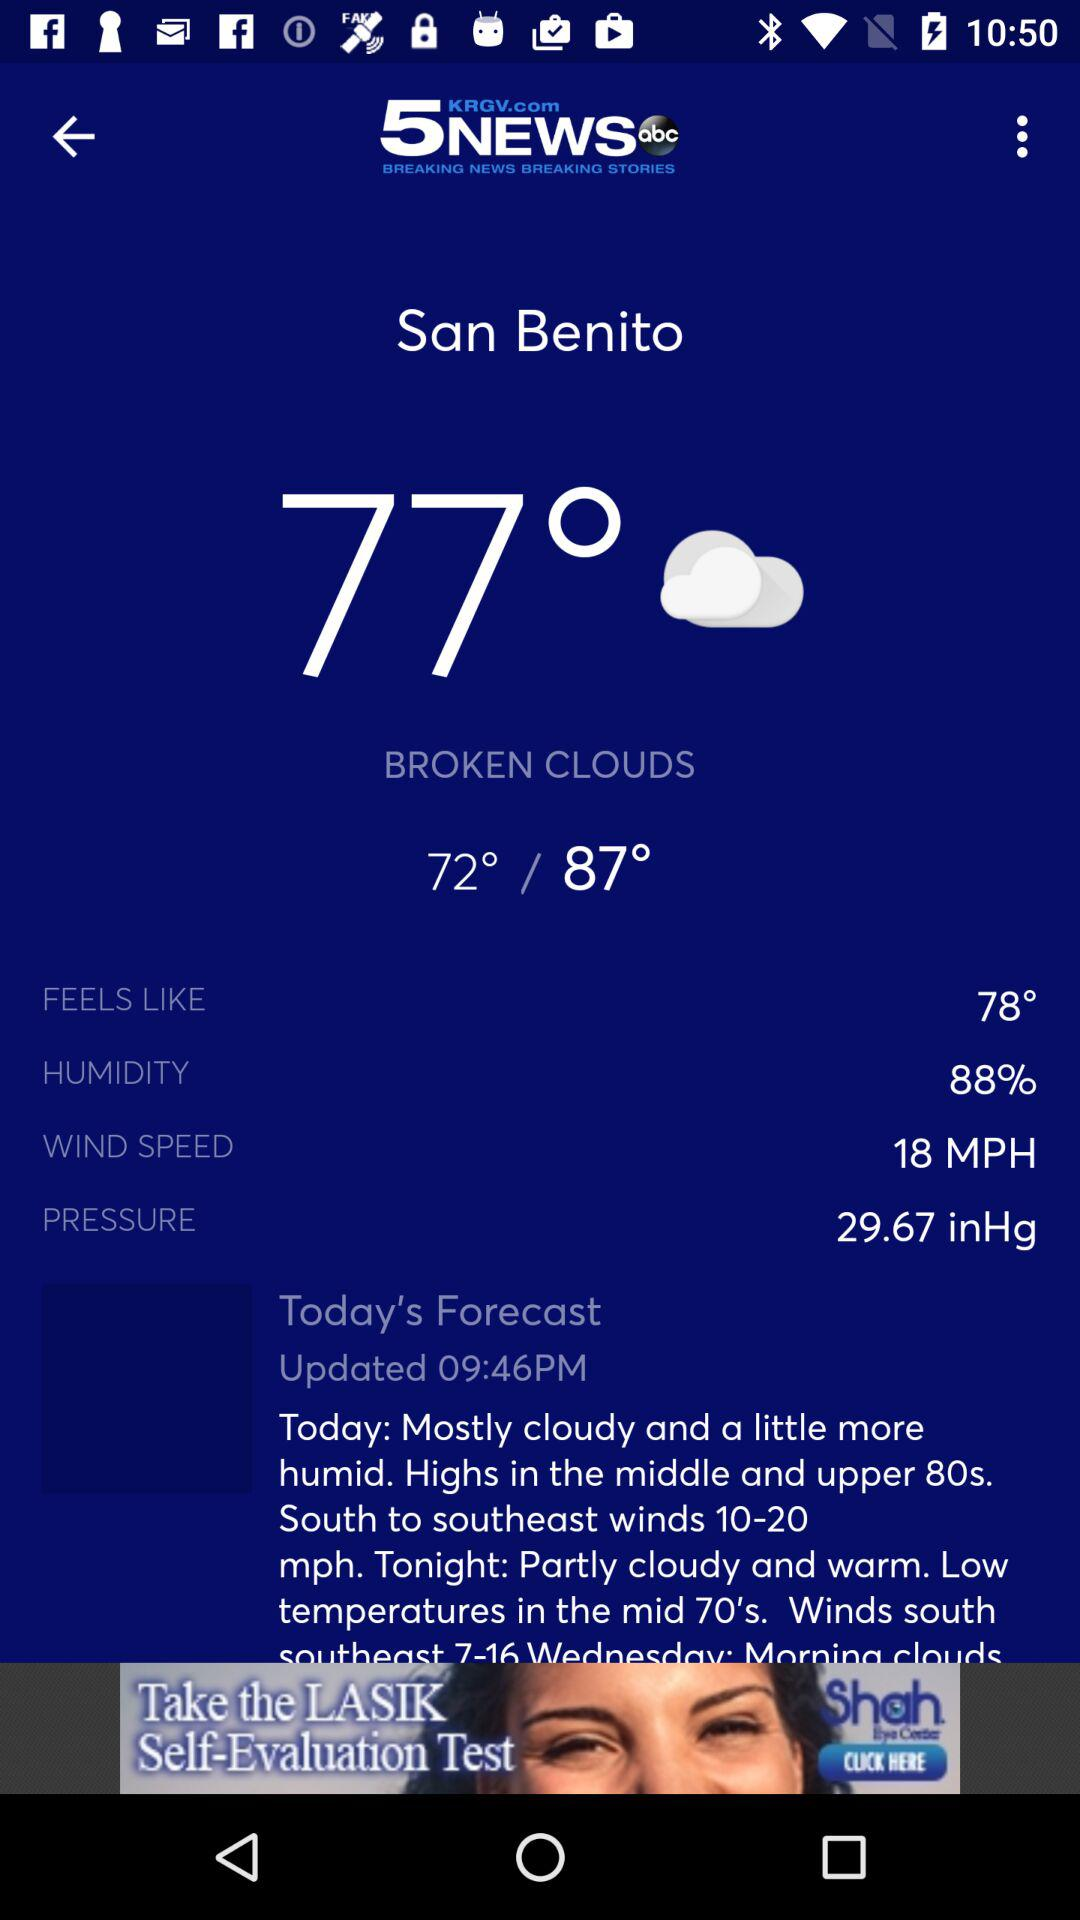What is the humidity percentage?
Answer the question using a single word or phrase. 88% 